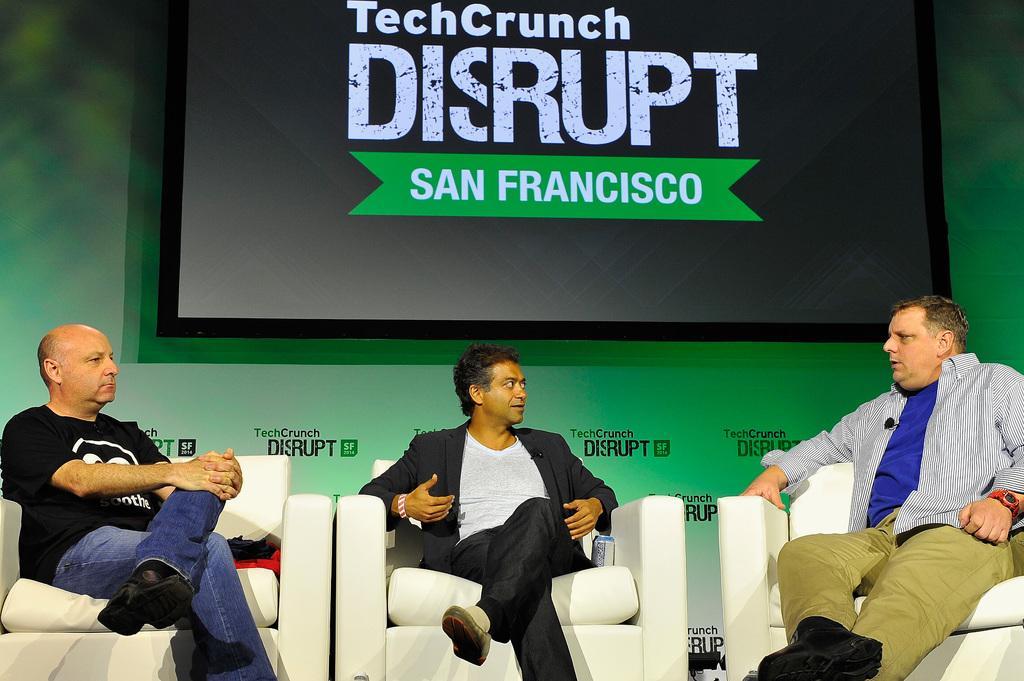Could you give a brief overview of what you see in this image? These three men sitting on chairs. On the background we can see wall and screen. 